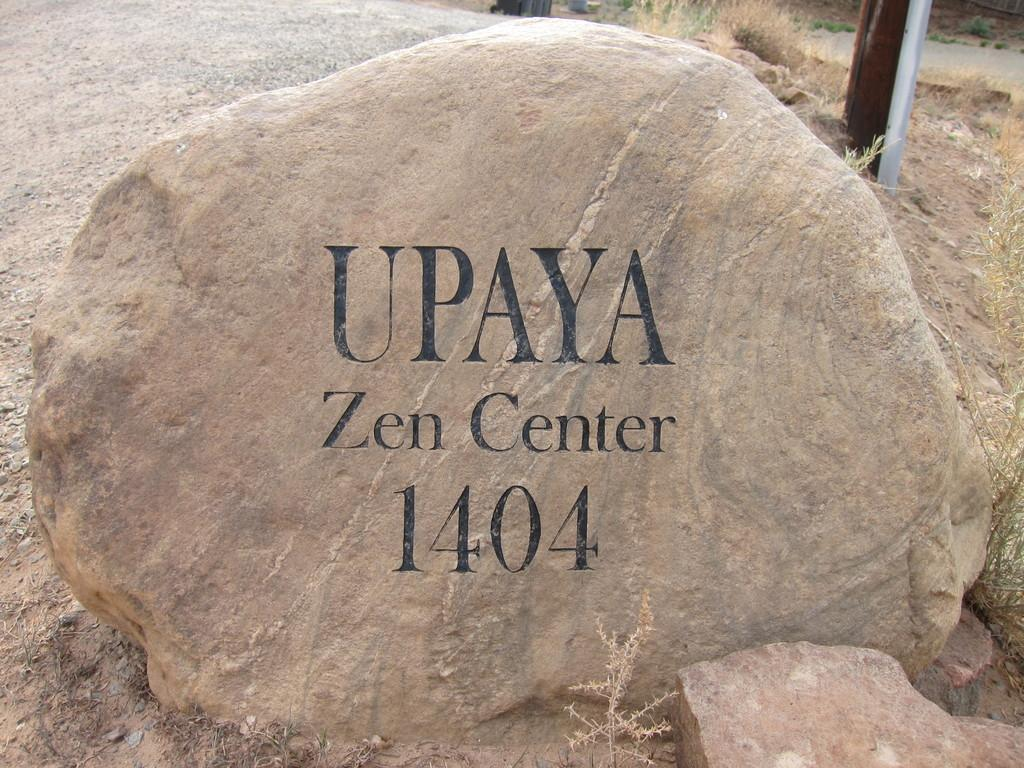What is the main object in the image? There is a rock in the image. What else can be seen in the image besides the rock? There is text visible in the image, as well as grass and a road. Can you describe the time of day when the image was taken? The image was taken during the day. What invention is being demonstrated by the rock in the image? There is no invention being demonstrated by the rock in the image; it is simply a rock. 